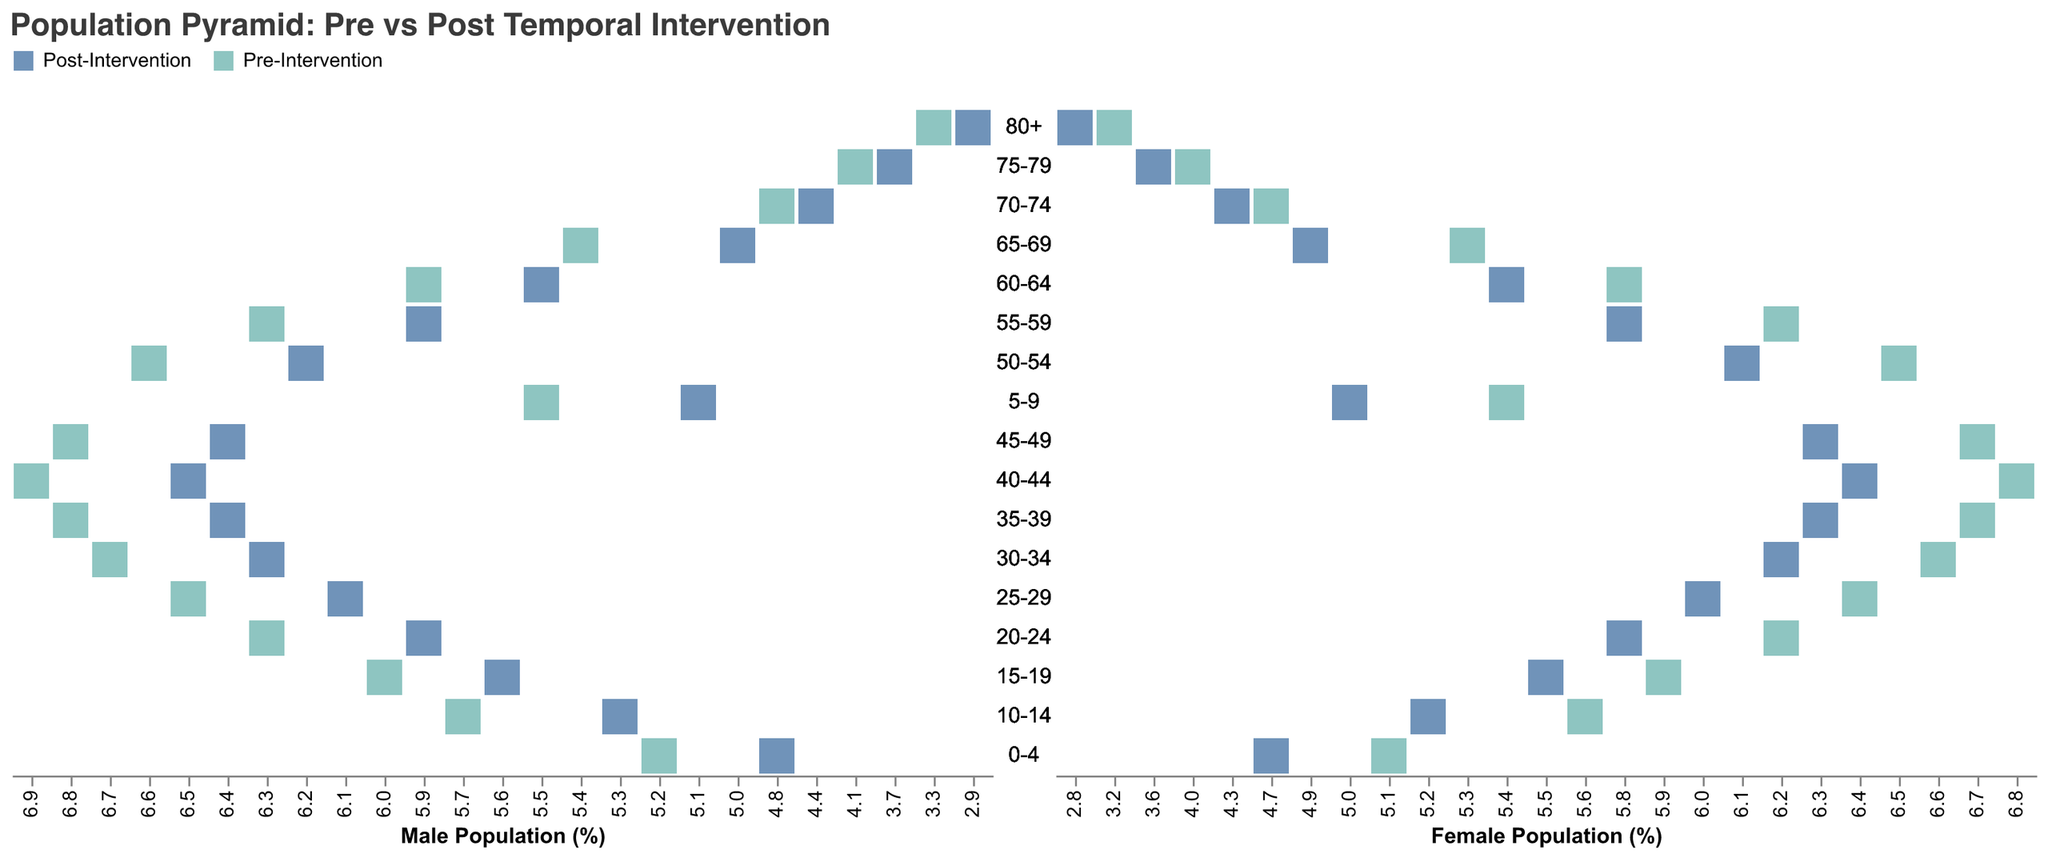What is the title of the figure? The title is usually found at the top of the figure. For this plot, it is positioned center-aligned and displayed in a larger font size for emphasis.
Answer: Population Pyramid: Pre vs Post Temporal Intervention Which gender and intervention has the highest value for the 25-29 age group? By looking at the bar corresponding to the 25-29 age group on the male side (left part of the pyramid) and comparing both the pre- and post-intervention values, the highest value is from "Pre-Intervention Males" with -6.5.
Answer: Pre-Intervention Males How does the population percentage for the 0-4 age group change from pre- to post-intervention for both males and females? Pre-intervention values are indicated by one color, and post-intervention by another. Comparing pre- vs post-intervention values for the 0-4 age group: male percentage changes from -5.2 to -4.8 (an increase), and female percentage changes from 5.1 to 4.7 (a decrease).
Answer: Males: -5.2 to -4.8, Females: 5.1 to 4.7 What is the difference between pre- and post-intervention percentages for males in the 35-39 age group? The pre-intervention percentage is -6.8, and the post-intervention percentage is -6.4 for the 35-39 age group male population. Calculating the difference: -6.8 - (-6.4) = -0.4.
Answer: -0.4 Which age group shows the most significant decrease for females post-intervention compared to pre-intervention? By comparing the pre-intervention and post-intervention values for females in all age groups, the age group 80+ shows the most significant decrease: from 3.2 to 2.8 (a decrease of 0.4).
Answer: 80+ What is the average population percentage for males aged 10-14 across both pre- and post-intervention periods? Pre-intervention value for 10-14 males is -5.7; post-intervention is -5.3. Calculate the average: (-5.7 + (-5.3))/2 = -5.5.
Answer: -5.5 In which age group do we see an equal pre- and post-intervention value for females? By comparing pre- and post-intervention values for females in each age group, no age group has equal values. All groups show differences.
Answer: None By how much did the population percentage of males aged 55-59 change post-intervention? The pre-intervention percentage for males aged 55-59 is -6.3 and post-intervention is -5.9. Calculate the change: -6.3 - (-5.9) = -0.4.
Answer: -0.4 Which age group shows the least change in population percentage for males post-intervention? Comparing the changes (absolute value differences) in population percentages for males across all age groups, the age group with the least change is the 75-79 group: from -4.1 to -3.7 (0.4).
Answer: 75-79 